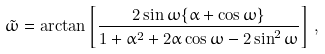<formula> <loc_0><loc_0><loc_500><loc_500>\tilde { \omega } = \arctan \left [ \frac { 2 \sin \omega \{ \alpha + \cos \omega \} } { 1 + \alpha ^ { 2 } + 2 \alpha \cos \omega - 2 \sin ^ { 2 } \omega } \right ] \, ,</formula> 